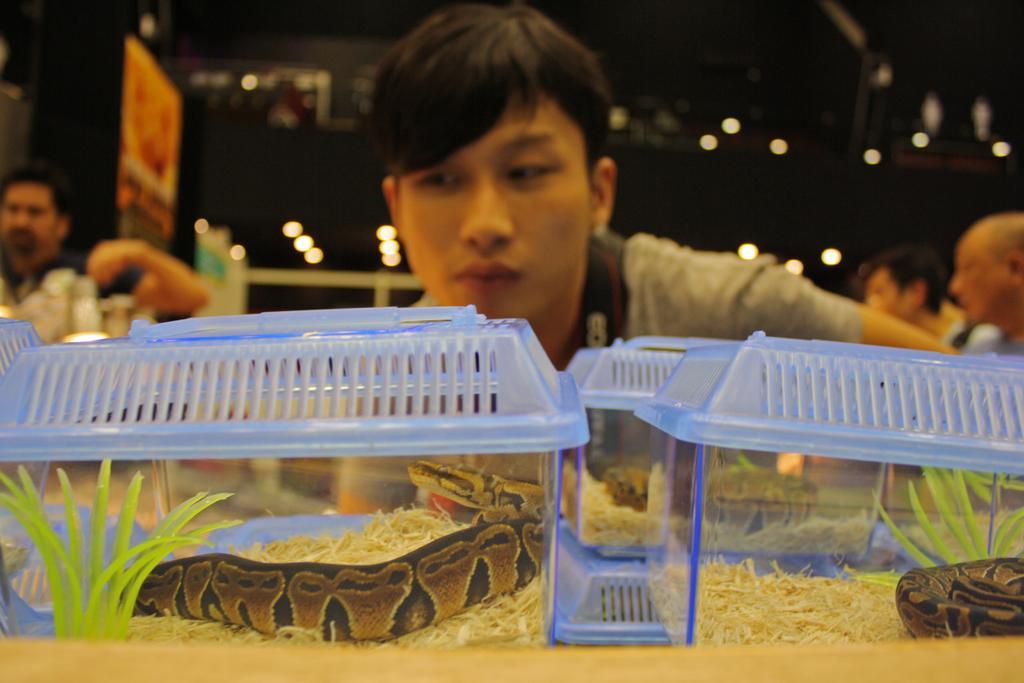Can you describe this image briefly? Here in this picture we can see some plastic containers with snakes in it present on the table over there, we can also see grass in the containers, beside them we can see people standing here and there and we can also see lights on the roof over there. 